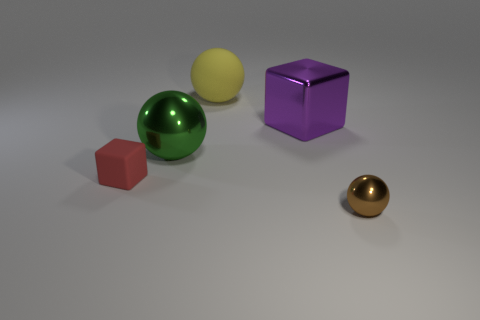There is a purple metal object that is the same shape as the red rubber object; what size is it?
Provide a succinct answer. Large. The thing that is in front of the red matte block has what shape?
Provide a succinct answer. Sphere. Do the tiny thing in front of the tiny red matte block and the cube that is left of the big cube have the same material?
Your response must be concise. No. There is a tiny red thing; what shape is it?
Provide a short and direct response. Cube. Is the number of small matte blocks that are behind the purple shiny thing the same as the number of things?
Provide a short and direct response. No. Are there any large blocks made of the same material as the big yellow ball?
Ensure brevity in your answer.  No. Does the object that is on the right side of the purple thing have the same shape as the tiny thing left of the big green ball?
Provide a succinct answer. No. Are there any small rubber blocks?
Offer a very short reply. Yes. The thing that is the same size as the brown ball is what color?
Your response must be concise. Red. What number of yellow rubber objects have the same shape as the green object?
Offer a terse response. 1. 